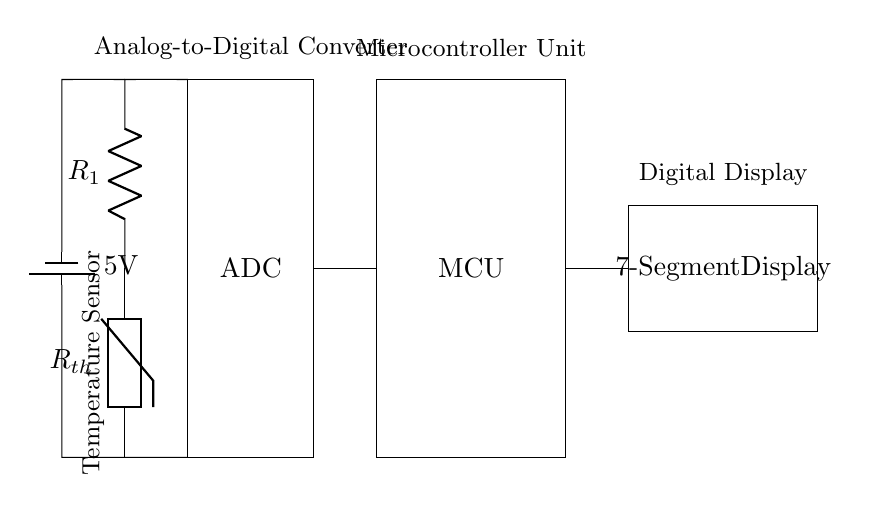What type of sensor is used in this circuit? The circuit uses a thermistor as the temperature sensor, which is indicated by the labeled component R_th in the diagram.
Answer: thermistor What does the ADC do in this circuit? The ADC, or Analog-to-Digital Converter, converts the analog voltage level from the thermistor voltage divider into a digital signal for the microcontroller.
Answer: converts analog to digital What is the battery voltage provided to the circuit? The circuit diagram indicates a battery labeled as 5V, which is the operating voltage supplied to the components.
Answer: 5V Which component is responsible for displaying the temperature? The seven-segment display is responsible for displaying the temperature readings processed by the microcontroller, as indicated in the diagram.
Answer: seven-segment display What is the purpose of the microcontroller in this circuit? The microcontroller processes the digital signal received from the ADC, enabling it to control the seven-segment display and manage the output.
Answer: process the signal What two components form a voltage divider with the thermistor? The thermistor (R_th) and resistor R1 form a voltage divider, as they are connected in series to determine the voltage that is fed into the ADC.
Answer: thermistor and R1 How does the temperature affect the resistance of the thermistor? As the temperature changes, the resistance of the thermistor varies inversely: when temperature increases, resistance generally decreases, affecting the output voltage seen by the ADC.
Answer: inversely 